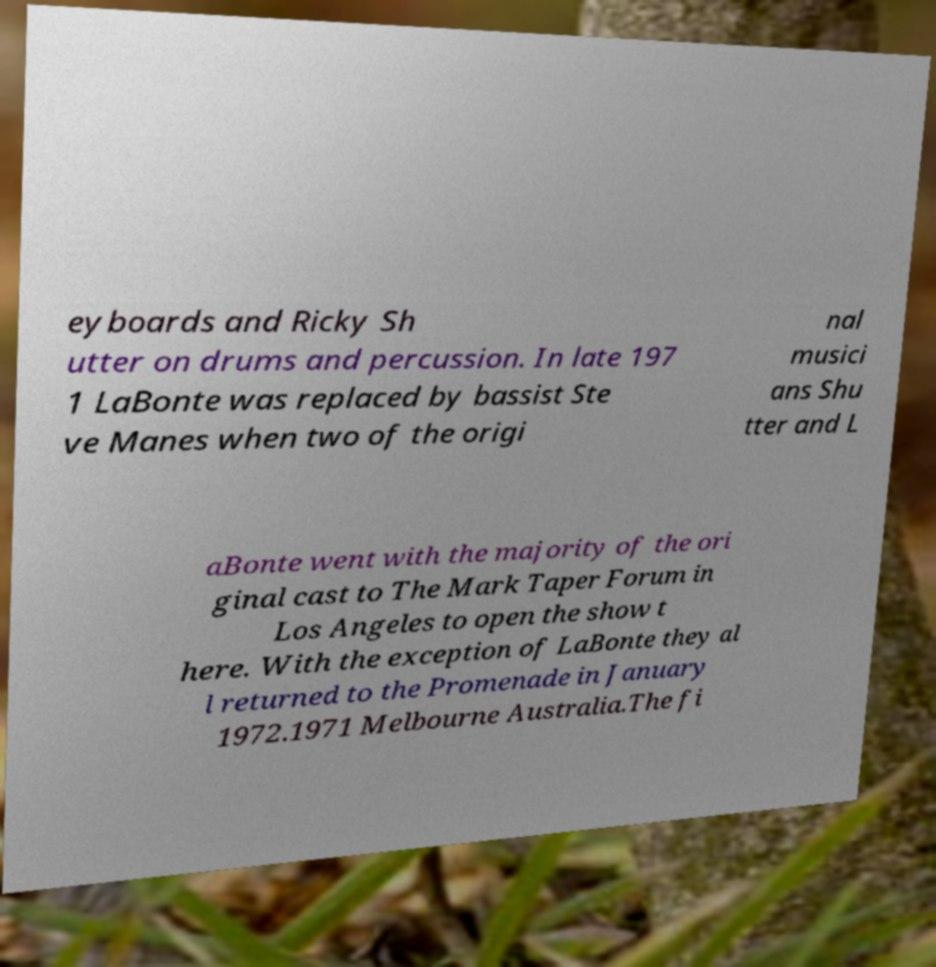Can you read and provide the text displayed in the image?This photo seems to have some interesting text. Can you extract and type it out for me? eyboards and Ricky Sh utter on drums and percussion. In late 197 1 LaBonte was replaced by bassist Ste ve Manes when two of the origi nal musici ans Shu tter and L aBonte went with the majority of the ori ginal cast to The Mark Taper Forum in Los Angeles to open the show t here. With the exception of LaBonte they al l returned to the Promenade in January 1972.1971 Melbourne Australia.The fi 